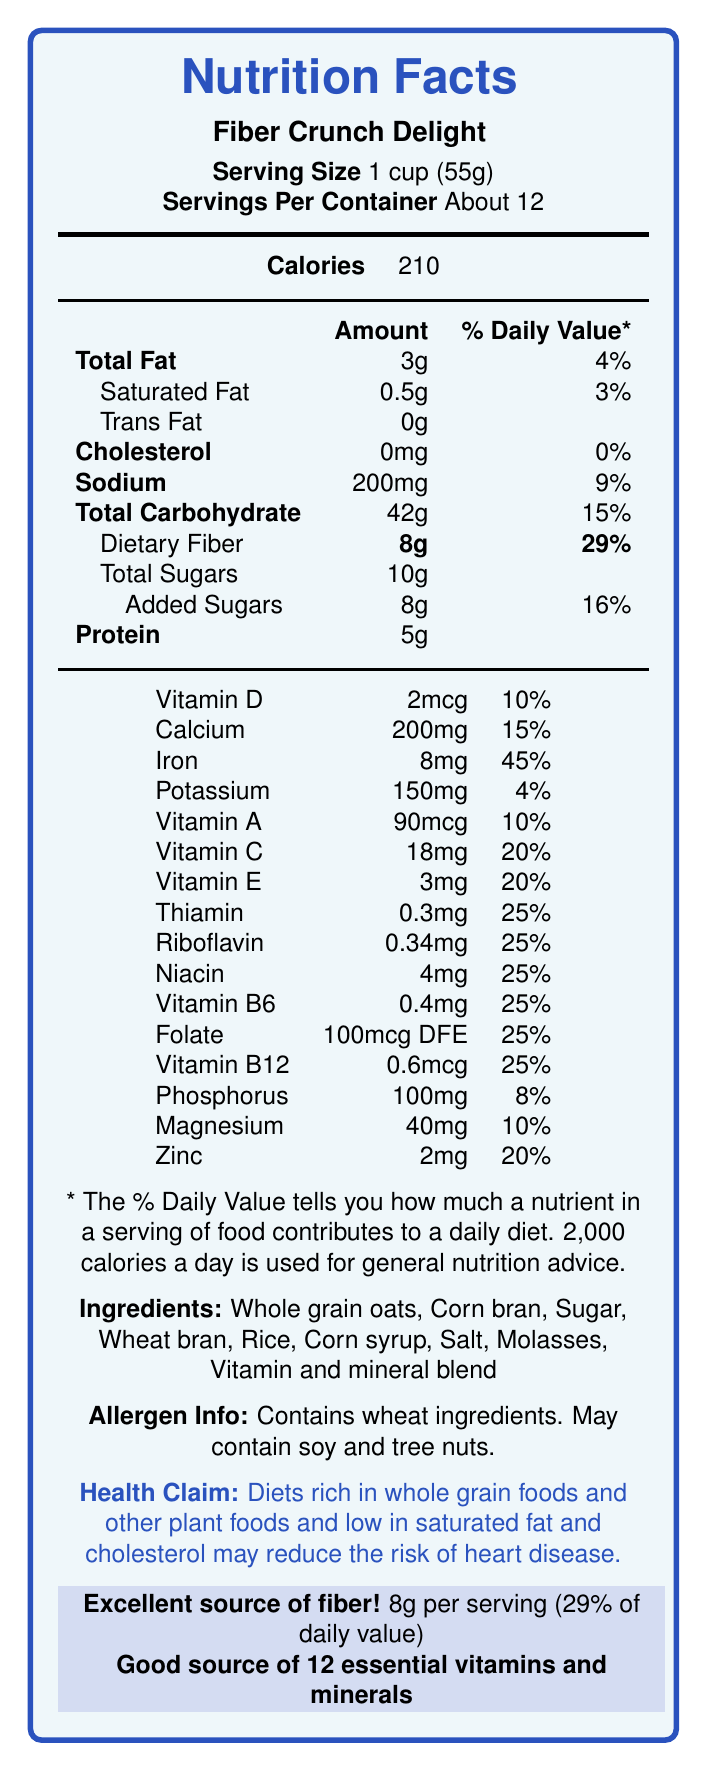What is the serving size for Fiber Crunch Delight? The document states that the serving size for Fiber Crunch Delight is 1 cup (55g).
Answer: 1 cup (55g) How many calories are in one serving of Fiber Crunch Delight? The document lists the calorie content per serving as 210.
Answer: 210 How much dietary fiber does one serving contain? The document shows that each serving contains 8g of dietary fiber.
Answer: 8g What is the percentage of the daily value for dietary fiber in one serving? The nutrition facts label indicates that 8g of dietary fiber is 29% of the daily value.
Answer: 29% Which vitamin has the highest percentage of daily value in one serving? The iron content per serving amounts to 45% of the daily value, which is the highest among the listed vitamins and minerals.
Answer: Iron What is the total fat content per serving? The document lists the total fat content per serving as 3g.
Answer: 3g What are the ingredients in Fiber Crunch Delight? The document lists all the ingredients, and they include whole grain oats, corn bran, sugar, wheat bran, rice, corn syrup, salt, molasses, and a vitamin and mineral blend.
Answer: Whole grain oats, Corn bran, Sugar, Wheat bran, Rice, Corn syrup, Salt, Molasses, Vitamin and mineral blend Does Fiber Crunch Delight contain any allergens? The allergen information indicates that the product contains wheat ingredients and may also contain soy and tree nuts.
Answer: Yes What is the daily value percentage for sodium in one serving? The label shows that there is 200mg of sodium per serving, which is 9% of the daily value.
Answer: 9% How many servings are there in one container of Fiber Crunch Delight? The document states that there are about 12 servings per container.
Answer: About 12 Which of the following vitamins or minerals has the lowest percentage of daily value per serving?
A. Calcium
B. Vitamin D
C. Potassium
D. Zinc The document indicates that potassium has 4% of the daily value per serving, which is the lowest among the given options.
Answer: C. Potassium How much added sugar is in one serving? 
1. 6g 
2. 8g 
3. 10g 
4. 12g The document specifies that one serving contains 8g of added sugars.
Answer: 2 Is Fiber Crunch Delight a good source of fiber? The document highlights that it is an excellent source of fiber with 8g per serving, which is 29% of the daily value.
Answer: Yes Summarize the main idea of the nutrition facts label for Fiber Crunch Delight. The document provides comprehensive nutrition information for Fiber Crunch Delight cereal, emphasizing its high fiber content and significant contributions to daily vitamin and mineral intake. The label aims to inform consumers about the nutritional benefits and potential health impacts of the cereal.
Answer: Fiber Crunch Delight is a breakfast cereal that is an excellent source of dietary fiber, containing 8g per serving (29% of the daily value). It also provides a variety of essential vitamins and minerals, while containing moderate amounts of calories, fats, and sugars. The label provides detailed nutritional values per serving and highlights health claims related to its ingredients. What is the health claim mentioned on the nutrition facts label? The health claim provided indicates that diets high in whole grains and low in saturated fats and cholesterol could potentially reduce heart disease risk.
Answer: Diets rich in whole grain foods and other plant foods and low in saturated fat and cholesterol may reduce the risk of heart disease. How much protein is in one serving of Fiber Crunch Delight? The document mentions that each serving contains 5g of protein.
Answer: 5g How much iron is in one serving? The label states that each serving contains 8mg of iron.
Answer: 8mg Can the document tell us the shelf life of the product? The document does not include any details regarding the shelf life of Fiber Crunch Delight.
Answer: Not enough information 